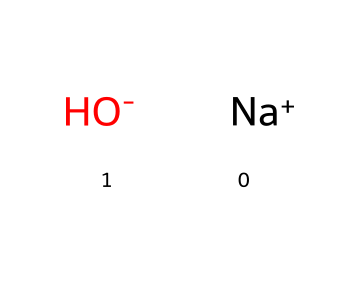What is the name of this chemical? The SMILES representation indicates the presence of sodium and hydroxide ions, which together form sodium hydroxide.
Answer: sodium hydroxide How many atoms are present in this chemical? In the SMILES representation, there are two distinct ions: one sodium atom and one oxygen atom combined with one hydrogen atom, totaling three atoms.
Answer: three What charge does the hydroxide ion carry? The presence of [OH-] in the SMILES notation shows that the hydroxide ion has a negative charge.
Answer: negative Which component of sodium hydroxide is responsible for its basic properties? The hydroxide ion (OH-) is responsible for the basic properties, as it can accept protons, making the solution alkaline.
Answer: hydroxide ion Is sodium hydroxide a strong base? Sodium hydroxide completely dissociates in water, releasing hydroxide ions, which classifies it as a strong base.
Answer: yes How is sodium hydroxide commonly used in property maintenance? Sodium hydroxide is often used to clean surfaces, as it can effectively remove grease, stains, and organic matter due to its strong alkaline nature.
Answer: cleaning agent 